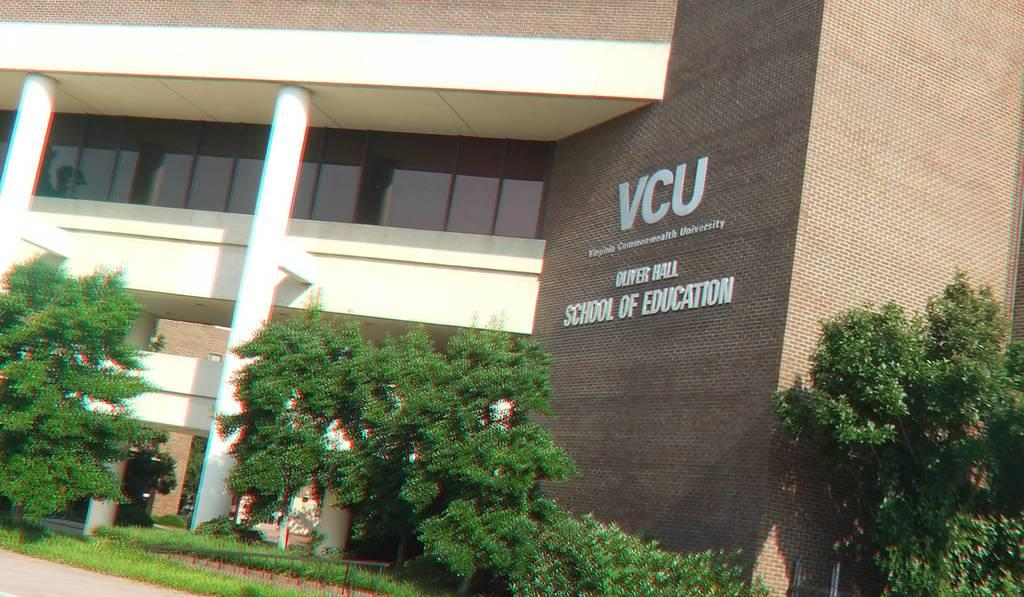What type of vegetation is present in the image? There are green trees in the image. Where are the trees located in relation to the image? The trees are located on the down side of the image. What type of structure is visible in the image? There is a big building in the image. On which side of the image is the building located? The building is on the right side of the image. Is there any text or name on the building? Yes, there is a name on the building. What type of fruit is hanging from the trees in the image? There is no fruit visible on the trees in the image; only green vegetation is present. How does the nerve system of the trees affect their growth in the image? There is no information about the nerve system of the trees in the image, as it is not relevant to the visual content. 